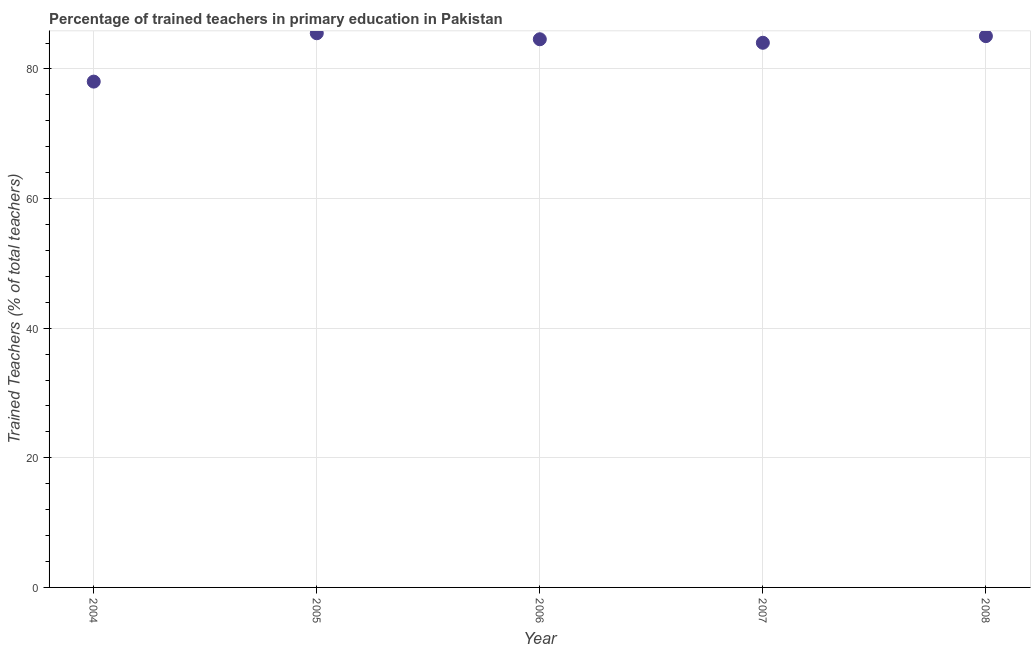What is the percentage of trained teachers in 2004?
Keep it short and to the point. 78.04. Across all years, what is the maximum percentage of trained teachers?
Offer a terse response. 85.51. Across all years, what is the minimum percentage of trained teachers?
Ensure brevity in your answer.  78.04. In which year was the percentage of trained teachers maximum?
Your answer should be very brief. 2005. In which year was the percentage of trained teachers minimum?
Provide a succinct answer. 2004. What is the sum of the percentage of trained teachers?
Your answer should be compact. 417.23. What is the difference between the percentage of trained teachers in 2004 and 2005?
Offer a very short reply. -7.46. What is the average percentage of trained teachers per year?
Ensure brevity in your answer.  83.45. What is the median percentage of trained teachers?
Ensure brevity in your answer.  84.58. In how many years, is the percentage of trained teachers greater than 4 %?
Keep it short and to the point. 5. What is the ratio of the percentage of trained teachers in 2004 to that in 2008?
Make the answer very short. 0.92. Is the percentage of trained teachers in 2005 less than that in 2007?
Ensure brevity in your answer.  No. What is the difference between the highest and the second highest percentage of trained teachers?
Your response must be concise. 0.44. What is the difference between the highest and the lowest percentage of trained teachers?
Your response must be concise. 7.46. Does the percentage of trained teachers monotonically increase over the years?
Provide a short and direct response. No. Are the values on the major ticks of Y-axis written in scientific E-notation?
Ensure brevity in your answer.  No. Does the graph contain grids?
Give a very brief answer. Yes. What is the title of the graph?
Give a very brief answer. Percentage of trained teachers in primary education in Pakistan. What is the label or title of the X-axis?
Your response must be concise. Year. What is the label or title of the Y-axis?
Provide a succinct answer. Trained Teachers (% of total teachers). What is the Trained Teachers (% of total teachers) in 2004?
Your response must be concise. 78.04. What is the Trained Teachers (% of total teachers) in 2005?
Provide a succinct answer. 85.51. What is the Trained Teachers (% of total teachers) in 2006?
Provide a short and direct response. 84.58. What is the Trained Teachers (% of total teachers) in 2007?
Provide a short and direct response. 84.04. What is the Trained Teachers (% of total teachers) in 2008?
Provide a short and direct response. 85.06. What is the difference between the Trained Teachers (% of total teachers) in 2004 and 2005?
Give a very brief answer. -7.46. What is the difference between the Trained Teachers (% of total teachers) in 2004 and 2006?
Offer a very short reply. -6.54. What is the difference between the Trained Teachers (% of total teachers) in 2004 and 2007?
Provide a succinct answer. -5.99. What is the difference between the Trained Teachers (% of total teachers) in 2004 and 2008?
Provide a succinct answer. -7.02. What is the difference between the Trained Teachers (% of total teachers) in 2005 and 2006?
Provide a succinct answer. 0.93. What is the difference between the Trained Teachers (% of total teachers) in 2005 and 2007?
Offer a terse response. 1.47. What is the difference between the Trained Teachers (% of total teachers) in 2005 and 2008?
Keep it short and to the point. 0.44. What is the difference between the Trained Teachers (% of total teachers) in 2006 and 2007?
Provide a succinct answer. 0.54. What is the difference between the Trained Teachers (% of total teachers) in 2006 and 2008?
Provide a short and direct response. -0.48. What is the difference between the Trained Teachers (% of total teachers) in 2007 and 2008?
Ensure brevity in your answer.  -1.03. What is the ratio of the Trained Teachers (% of total teachers) in 2004 to that in 2005?
Give a very brief answer. 0.91. What is the ratio of the Trained Teachers (% of total teachers) in 2004 to that in 2006?
Offer a very short reply. 0.92. What is the ratio of the Trained Teachers (% of total teachers) in 2004 to that in 2007?
Make the answer very short. 0.93. What is the ratio of the Trained Teachers (% of total teachers) in 2004 to that in 2008?
Your answer should be very brief. 0.92. 